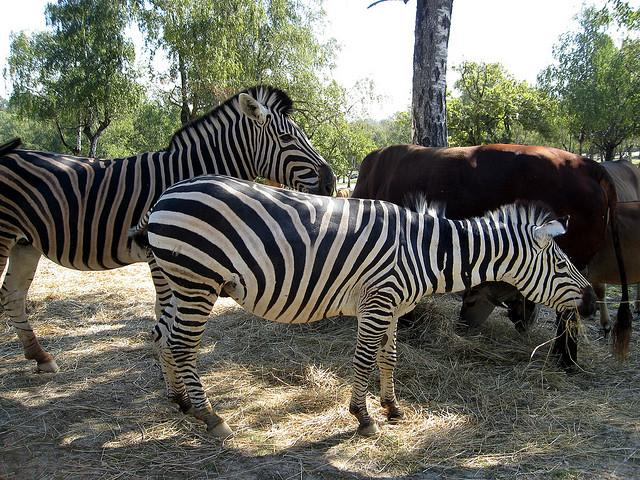Where are the animals? Please explain your reasoning. outdoors. The animals are not enclosed. they are surrounded by trees, grass, and the sky. 